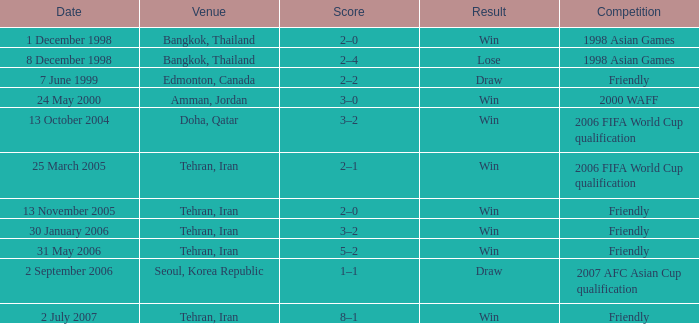What was the competitive event on 7 june 1999? Friendly. 